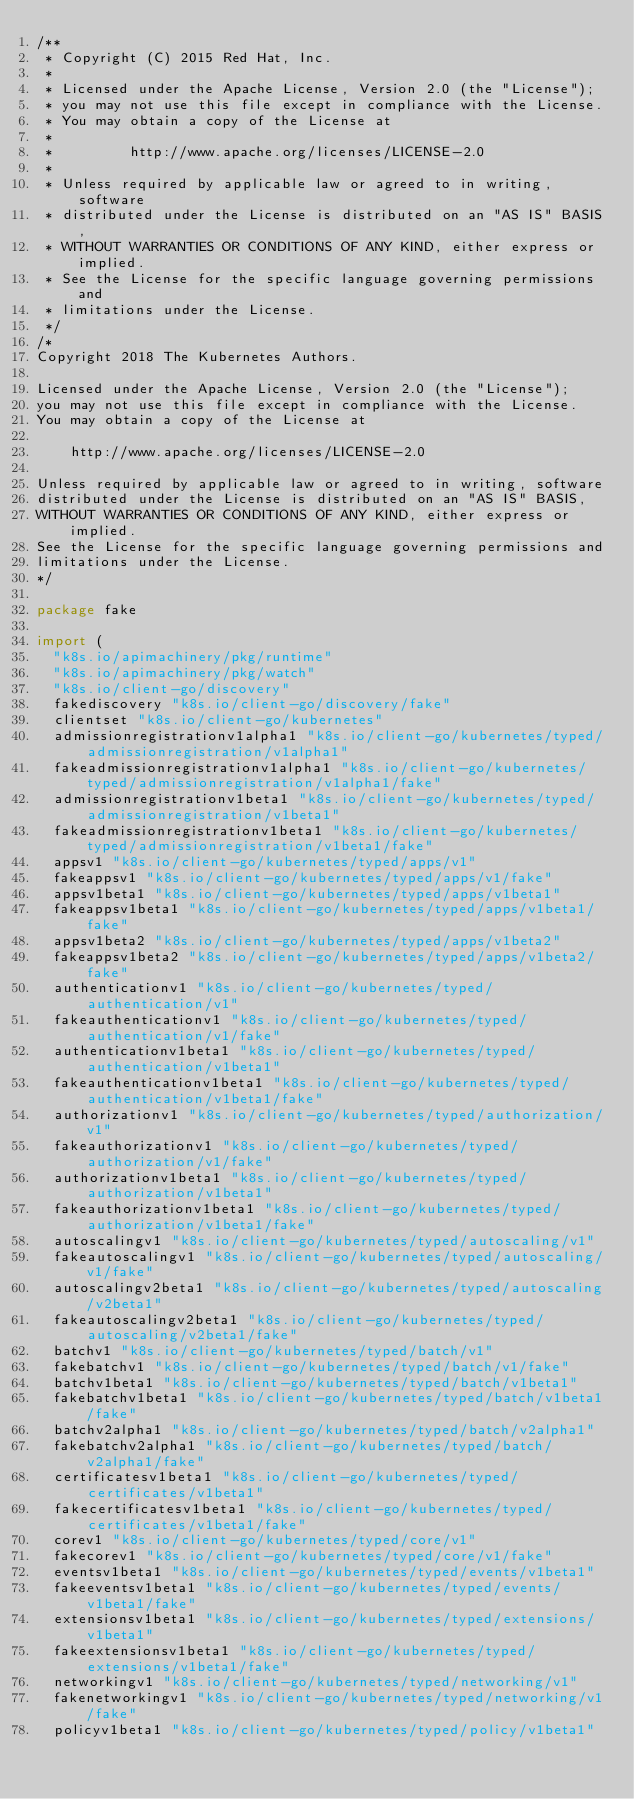Convert code to text. <code><loc_0><loc_0><loc_500><loc_500><_Go_>/**
 * Copyright (C) 2015 Red Hat, Inc.
 *
 * Licensed under the Apache License, Version 2.0 (the "License");
 * you may not use this file except in compliance with the License.
 * You may obtain a copy of the License at
 *
 *         http://www.apache.org/licenses/LICENSE-2.0
 *
 * Unless required by applicable law or agreed to in writing, software
 * distributed under the License is distributed on an "AS IS" BASIS,
 * WITHOUT WARRANTIES OR CONDITIONS OF ANY KIND, either express or implied.
 * See the License for the specific language governing permissions and
 * limitations under the License.
 */
/*
Copyright 2018 The Kubernetes Authors.

Licensed under the Apache License, Version 2.0 (the "License");
you may not use this file except in compliance with the License.
You may obtain a copy of the License at

    http://www.apache.org/licenses/LICENSE-2.0

Unless required by applicable law or agreed to in writing, software
distributed under the License is distributed on an "AS IS" BASIS,
WITHOUT WARRANTIES OR CONDITIONS OF ANY KIND, either express or implied.
See the License for the specific language governing permissions and
limitations under the License.
*/

package fake

import (
	"k8s.io/apimachinery/pkg/runtime"
	"k8s.io/apimachinery/pkg/watch"
	"k8s.io/client-go/discovery"
	fakediscovery "k8s.io/client-go/discovery/fake"
	clientset "k8s.io/client-go/kubernetes"
	admissionregistrationv1alpha1 "k8s.io/client-go/kubernetes/typed/admissionregistration/v1alpha1"
	fakeadmissionregistrationv1alpha1 "k8s.io/client-go/kubernetes/typed/admissionregistration/v1alpha1/fake"
	admissionregistrationv1beta1 "k8s.io/client-go/kubernetes/typed/admissionregistration/v1beta1"
	fakeadmissionregistrationv1beta1 "k8s.io/client-go/kubernetes/typed/admissionregistration/v1beta1/fake"
	appsv1 "k8s.io/client-go/kubernetes/typed/apps/v1"
	fakeappsv1 "k8s.io/client-go/kubernetes/typed/apps/v1/fake"
	appsv1beta1 "k8s.io/client-go/kubernetes/typed/apps/v1beta1"
	fakeappsv1beta1 "k8s.io/client-go/kubernetes/typed/apps/v1beta1/fake"
	appsv1beta2 "k8s.io/client-go/kubernetes/typed/apps/v1beta2"
	fakeappsv1beta2 "k8s.io/client-go/kubernetes/typed/apps/v1beta2/fake"
	authenticationv1 "k8s.io/client-go/kubernetes/typed/authentication/v1"
	fakeauthenticationv1 "k8s.io/client-go/kubernetes/typed/authentication/v1/fake"
	authenticationv1beta1 "k8s.io/client-go/kubernetes/typed/authentication/v1beta1"
	fakeauthenticationv1beta1 "k8s.io/client-go/kubernetes/typed/authentication/v1beta1/fake"
	authorizationv1 "k8s.io/client-go/kubernetes/typed/authorization/v1"
	fakeauthorizationv1 "k8s.io/client-go/kubernetes/typed/authorization/v1/fake"
	authorizationv1beta1 "k8s.io/client-go/kubernetes/typed/authorization/v1beta1"
	fakeauthorizationv1beta1 "k8s.io/client-go/kubernetes/typed/authorization/v1beta1/fake"
	autoscalingv1 "k8s.io/client-go/kubernetes/typed/autoscaling/v1"
	fakeautoscalingv1 "k8s.io/client-go/kubernetes/typed/autoscaling/v1/fake"
	autoscalingv2beta1 "k8s.io/client-go/kubernetes/typed/autoscaling/v2beta1"
	fakeautoscalingv2beta1 "k8s.io/client-go/kubernetes/typed/autoscaling/v2beta1/fake"
	batchv1 "k8s.io/client-go/kubernetes/typed/batch/v1"
	fakebatchv1 "k8s.io/client-go/kubernetes/typed/batch/v1/fake"
	batchv1beta1 "k8s.io/client-go/kubernetes/typed/batch/v1beta1"
	fakebatchv1beta1 "k8s.io/client-go/kubernetes/typed/batch/v1beta1/fake"
	batchv2alpha1 "k8s.io/client-go/kubernetes/typed/batch/v2alpha1"
	fakebatchv2alpha1 "k8s.io/client-go/kubernetes/typed/batch/v2alpha1/fake"
	certificatesv1beta1 "k8s.io/client-go/kubernetes/typed/certificates/v1beta1"
	fakecertificatesv1beta1 "k8s.io/client-go/kubernetes/typed/certificates/v1beta1/fake"
	corev1 "k8s.io/client-go/kubernetes/typed/core/v1"
	fakecorev1 "k8s.io/client-go/kubernetes/typed/core/v1/fake"
	eventsv1beta1 "k8s.io/client-go/kubernetes/typed/events/v1beta1"
	fakeeventsv1beta1 "k8s.io/client-go/kubernetes/typed/events/v1beta1/fake"
	extensionsv1beta1 "k8s.io/client-go/kubernetes/typed/extensions/v1beta1"
	fakeextensionsv1beta1 "k8s.io/client-go/kubernetes/typed/extensions/v1beta1/fake"
	networkingv1 "k8s.io/client-go/kubernetes/typed/networking/v1"
	fakenetworkingv1 "k8s.io/client-go/kubernetes/typed/networking/v1/fake"
	policyv1beta1 "k8s.io/client-go/kubernetes/typed/policy/v1beta1"</code> 